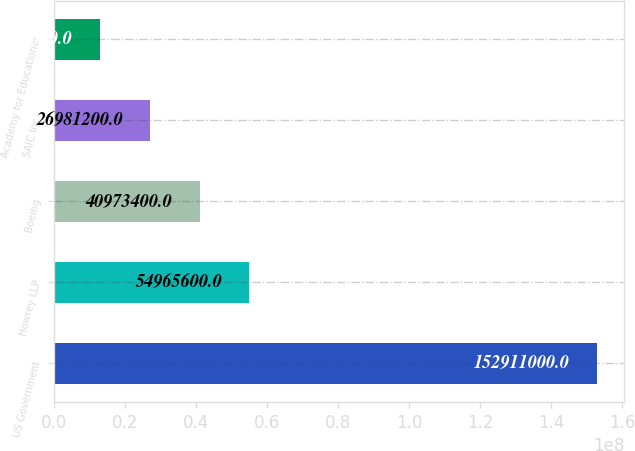Convert chart to OTSL. <chart><loc_0><loc_0><loc_500><loc_500><bar_chart><fcel>US Government<fcel>Howrey LLP<fcel>Boeing<fcel>SAIC Inc<fcel>Academy for Educational<nl><fcel>1.52911e+08<fcel>5.49656e+07<fcel>4.09734e+07<fcel>2.69812e+07<fcel>1.2989e+07<nl></chart> 